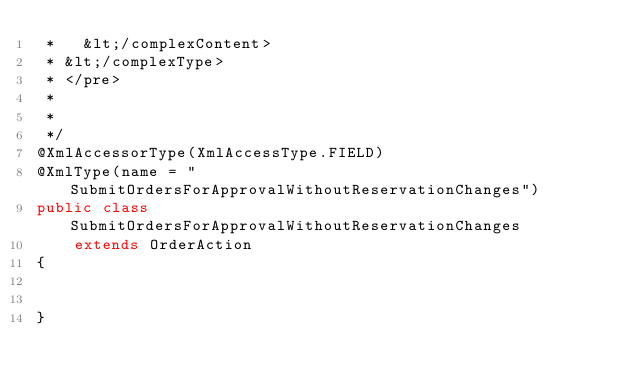<code> <loc_0><loc_0><loc_500><loc_500><_Java_> *   &lt;/complexContent>
 * &lt;/complexType>
 * </pre>
 * 
 * 
 */
@XmlAccessorType(XmlAccessType.FIELD)
@XmlType(name = "SubmitOrdersForApprovalWithoutReservationChanges")
public class SubmitOrdersForApprovalWithoutReservationChanges
    extends OrderAction
{


}
</code> 